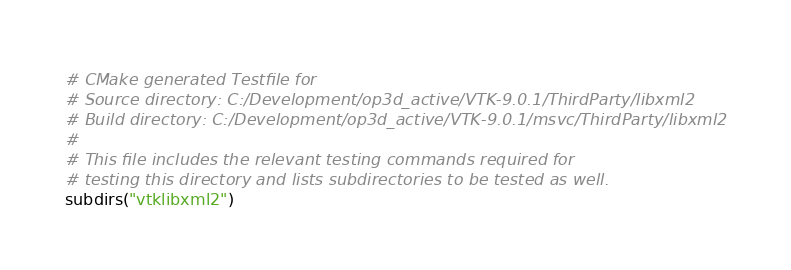Convert code to text. <code><loc_0><loc_0><loc_500><loc_500><_CMake_># CMake generated Testfile for 
# Source directory: C:/Development/op3d_active/VTK-9.0.1/ThirdParty/libxml2
# Build directory: C:/Development/op3d_active/VTK-9.0.1/msvc/ThirdParty/libxml2
# 
# This file includes the relevant testing commands required for 
# testing this directory and lists subdirectories to be tested as well.
subdirs("vtklibxml2")
</code> 